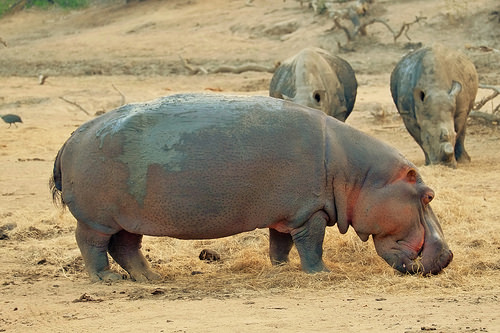<image>
Is the hippo behind the ground? No. The hippo is not behind the ground. From this viewpoint, the hippo appears to be positioned elsewhere in the scene. 